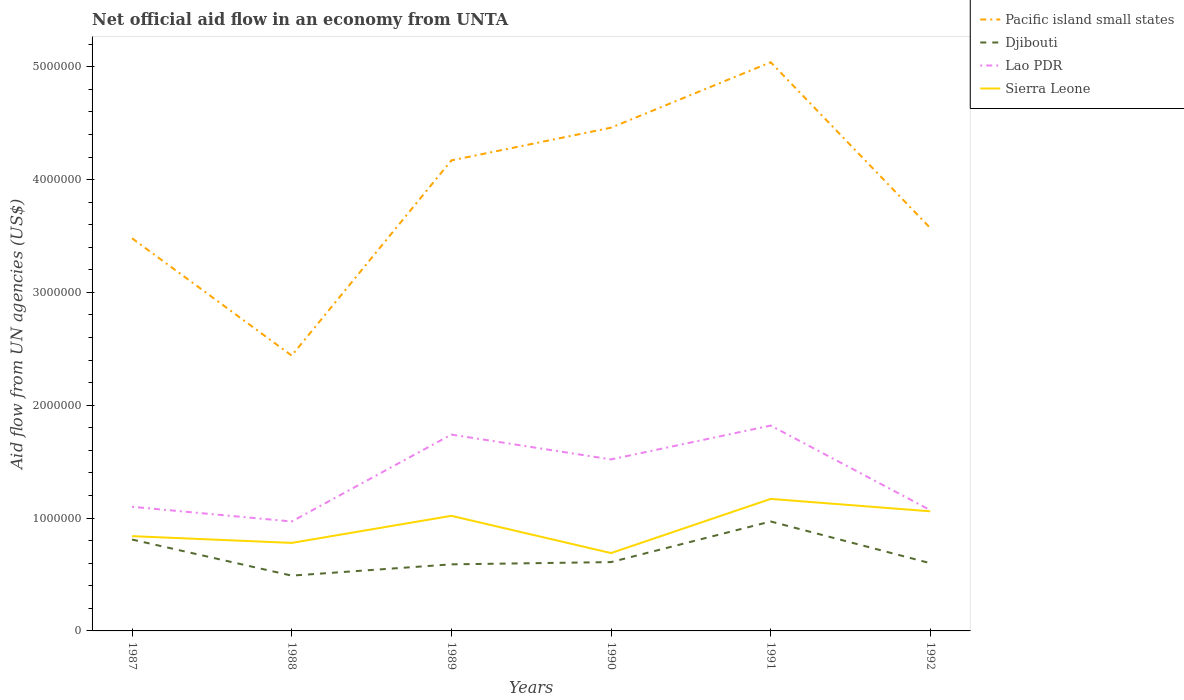How many different coloured lines are there?
Ensure brevity in your answer.  4. Does the line corresponding to Lao PDR intersect with the line corresponding to Pacific island small states?
Offer a terse response. No. Is the number of lines equal to the number of legend labels?
Keep it short and to the point. Yes. Across all years, what is the maximum net official aid flow in Pacific island small states?
Give a very brief answer. 2.44e+06. What is the total net official aid flow in Pacific island small states in the graph?
Ensure brevity in your answer.  -2.02e+06. What is the difference between the highest and the second highest net official aid flow in Lao PDR?
Make the answer very short. 8.50e+05. What is the difference between the highest and the lowest net official aid flow in Djibouti?
Your answer should be compact. 2. How many lines are there?
Ensure brevity in your answer.  4. Are the values on the major ticks of Y-axis written in scientific E-notation?
Your answer should be very brief. No. What is the title of the graph?
Your answer should be compact. Net official aid flow in an economy from UNTA. What is the label or title of the X-axis?
Provide a succinct answer. Years. What is the label or title of the Y-axis?
Ensure brevity in your answer.  Aid flow from UN agencies (US$). What is the Aid flow from UN agencies (US$) of Pacific island small states in 1987?
Make the answer very short. 3.48e+06. What is the Aid flow from UN agencies (US$) in Djibouti in 1987?
Provide a succinct answer. 8.10e+05. What is the Aid flow from UN agencies (US$) of Lao PDR in 1987?
Provide a succinct answer. 1.10e+06. What is the Aid flow from UN agencies (US$) of Sierra Leone in 1987?
Your response must be concise. 8.40e+05. What is the Aid flow from UN agencies (US$) of Pacific island small states in 1988?
Make the answer very short. 2.44e+06. What is the Aid flow from UN agencies (US$) in Lao PDR in 1988?
Offer a very short reply. 9.70e+05. What is the Aid flow from UN agencies (US$) of Sierra Leone in 1988?
Your response must be concise. 7.80e+05. What is the Aid flow from UN agencies (US$) of Pacific island small states in 1989?
Ensure brevity in your answer.  4.17e+06. What is the Aid flow from UN agencies (US$) of Djibouti in 1989?
Make the answer very short. 5.90e+05. What is the Aid flow from UN agencies (US$) in Lao PDR in 1989?
Give a very brief answer. 1.74e+06. What is the Aid flow from UN agencies (US$) in Sierra Leone in 1989?
Keep it short and to the point. 1.02e+06. What is the Aid flow from UN agencies (US$) of Pacific island small states in 1990?
Offer a very short reply. 4.46e+06. What is the Aid flow from UN agencies (US$) in Djibouti in 1990?
Provide a short and direct response. 6.10e+05. What is the Aid flow from UN agencies (US$) in Lao PDR in 1990?
Your response must be concise. 1.52e+06. What is the Aid flow from UN agencies (US$) of Sierra Leone in 1990?
Provide a short and direct response. 6.90e+05. What is the Aid flow from UN agencies (US$) in Pacific island small states in 1991?
Your answer should be compact. 5.04e+06. What is the Aid flow from UN agencies (US$) of Djibouti in 1991?
Your answer should be compact. 9.70e+05. What is the Aid flow from UN agencies (US$) of Lao PDR in 1991?
Keep it short and to the point. 1.82e+06. What is the Aid flow from UN agencies (US$) of Sierra Leone in 1991?
Offer a very short reply. 1.17e+06. What is the Aid flow from UN agencies (US$) of Pacific island small states in 1992?
Keep it short and to the point. 3.57e+06. What is the Aid flow from UN agencies (US$) of Lao PDR in 1992?
Ensure brevity in your answer.  1.07e+06. What is the Aid flow from UN agencies (US$) of Sierra Leone in 1992?
Keep it short and to the point. 1.06e+06. Across all years, what is the maximum Aid flow from UN agencies (US$) of Pacific island small states?
Your response must be concise. 5.04e+06. Across all years, what is the maximum Aid flow from UN agencies (US$) in Djibouti?
Provide a succinct answer. 9.70e+05. Across all years, what is the maximum Aid flow from UN agencies (US$) of Lao PDR?
Offer a very short reply. 1.82e+06. Across all years, what is the maximum Aid flow from UN agencies (US$) in Sierra Leone?
Keep it short and to the point. 1.17e+06. Across all years, what is the minimum Aid flow from UN agencies (US$) in Pacific island small states?
Your response must be concise. 2.44e+06. Across all years, what is the minimum Aid flow from UN agencies (US$) of Lao PDR?
Your answer should be compact. 9.70e+05. Across all years, what is the minimum Aid flow from UN agencies (US$) of Sierra Leone?
Offer a terse response. 6.90e+05. What is the total Aid flow from UN agencies (US$) in Pacific island small states in the graph?
Give a very brief answer. 2.32e+07. What is the total Aid flow from UN agencies (US$) of Djibouti in the graph?
Keep it short and to the point. 4.07e+06. What is the total Aid flow from UN agencies (US$) in Lao PDR in the graph?
Your answer should be compact. 8.22e+06. What is the total Aid flow from UN agencies (US$) of Sierra Leone in the graph?
Keep it short and to the point. 5.56e+06. What is the difference between the Aid flow from UN agencies (US$) of Pacific island small states in 1987 and that in 1988?
Provide a succinct answer. 1.04e+06. What is the difference between the Aid flow from UN agencies (US$) of Djibouti in 1987 and that in 1988?
Make the answer very short. 3.20e+05. What is the difference between the Aid flow from UN agencies (US$) of Lao PDR in 1987 and that in 1988?
Offer a terse response. 1.30e+05. What is the difference between the Aid flow from UN agencies (US$) of Sierra Leone in 1987 and that in 1988?
Your answer should be compact. 6.00e+04. What is the difference between the Aid flow from UN agencies (US$) in Pacific island small states in 1987 and that in 1989?
Ensure brevity in your answer.  -6.90e+05. What is the difference between the Aid flow from UN agencies (US$) in Lao PDR in 1987 and that in 1989?
Keep it short and to the point. -6.40e+05. What is the difference between the Aid flow from UN agencies (US$) of Pacific island small states in 1987 and that in 1990?
Your answer should be compact. -9.80e+05. What is the difference between the Aid flow from UN agencies (US$) of Djibouti in 1987 and that in 1990?
Ensure brevity in your answer.  2.00e+05. What is the difference between the Aid flow from UN agencies (US$) in Lao PDR in 1987 and that in 1990?
Provide a short and direct response. -4.20e+05. What is the difference between the Aid flow from UN agencies (US$) in Pacific island small states in 1987 and that in 1991?
Your answer should be compact. -1.56e+06. What is the difference between the Aid flow from UN agencies (US$) of Djibouti in 1987 and that in 1991?
Your response must be concise. -1.60e+05. What is the difference between the Aid flow from UN agencies (US$) of Lao PDR in 1987 and that in 1991?
Provide a succinct answer. -7.20e+05. What is the difference between the Aid flow from UN agencies (US$) in Sierra Leone in 1987 and that in 1991?
Your answer should be compact. -3.30e+05. What is the difference between the Aid flow from UN agencies (US$) in Pacific island small states in 1987 and that in 1992?
Offer a terse response. -9.00e+04. What is the difference between the Aid flow from UN agencies (US$) in Djibouti in 1987 and that in 1992?
Offer a very short reply. 2.10e+05. What is the difference between the Aid flow from UN agencies (US$) of Sierra Leone in 1987 and that in 1992?
Keep it short and to the point. -2.20e+05. What is the difference between the Aid flow from UN agencies (US$) of Pacific island small states in 1988 and that in 1989?
Offer a terse response. -1.73e+06. What is the difference between the Aid flow from UN agencies (US$) in Lao PDR in 1988 and that in 1989?
Your answer should be very brief. -7.70e+05. What is the difference between the Aid flow from UN agencies (US$) in Sierra Leone in 1988 and that in 1989?
Offer a terse response. -2.40e+05. What is the difference between the Aid flow from UN agencies (US$) of Pacific island small states in 1988 and that in 1990?
Your answer should be compact. -2.02e+06. What is the difference between the Aid flow from UN agencies (US$) in Lao PDR in 1988 and that in 1990?
Keep it short and to the point. -5.50e+05. What is the difference between the Aid flow from UN agencies (US$) in Sierra Leone in 1988 and that in 1990?
Your answer should be very brief. 9.00e+04. What is the difference between the Aid flow from UN agencies (US$) in Pacific island small states in 1988 and that in 1991?
Offer a terse response. -2.60e+06. What is the difference between the Aid flow from UN agencies (US$) in Djibouti in 1988 and that in 1991?
Give a very brief answer. -4.80e+05. What is the difference between the Aid flow from UN agencies (US$) in Lao PDR in 1988 and that in 1991?
Provide a short and direct response. -8.50e+05. What is the difference between the Aid flow from UN agencies (US$) of Sierra Leone in 1988 and that in 1991?
Keep it short and to the point. -3.90e+05. What is the difference between the Aid flow from UN agencies (US$) in Pacific island small states in 1988 and that in 1992?
Offer a terse response. -1.13e+06. What is the difference between the Aid flow from UN agencies (US$) of Djibouti in 1988 and that in 1992?
Keep it short and to the point. -1.10e+05. What is the difference between the Aid flow from UN agencies (US$) in Sierra Leone in 1988 and that in 1992?
Your answer should be compact. -2.80e+05. What is the difference between the Aid flow from UN agencies (US$) in Sierra Leone in 1989 and that in 1990?
Make the answer very short. 3.30e+05. What is the difference between the Aid flow from UN agencies (US$) of Pacific island small states in 1989 and that in 1991?
Ensure brevity in your answer.  -8.70e+05. What is the difference between the Aid flow from UN agencies (US$) of Djibouti in 1989 and that in 1991?
Provide a succinct answer. -3.80e+05. What is the difference between the Aid flow from UN agencies (US$) in Pacific island small states in 1989 and that in 1992?
Your response must be concise. 6.00e+05. What is the difference between the Aid flow from UN agencies (US$) of Lao PDR in 1989 and that in 1992?
Offer a very short reply. 6.70e+05. What is the difference between the Aid flow from UN agencies (US$) in Pacific island small states in 1990 and that in 1991?
Your response must be concise. -5.80e+05. What is the difference between the Aid flow from UN agencies (US$) in Djibouti in 1990 and that in 1991?
Offer a terse response. -3.60e+05. What is the difference between the Aid flow from UN agencies (US$) in Lao PDR in 1990 and that in 1991?
Ensure brevity in your answer.  -3.00e+05. What is the difference between the Aid flow from UN agencies (US$) in Sierra Leone in 1990 and that in 1991?
Make the answer very short. -4.80e+05. What is the difference between the Aid flow from UN agencies (US$) of Pacific island small states in 1990 and that in 1992?
Offer a very short reply. 8.90e+05. What is the difference between the Aid flow from UN agencies (US$) in Djibouti in 1990 and that in 1992?
Keep it short and to the point. 10000. What is the difference between the Aid flow from UN agencies (US$) in Sierra Leone in 1990 and that in 1992?
Your answer should be very brief. -3.70e+05. What is the difference between the Aid flow from UN agencies (US$) of Pacific island small states in 1991 and that in 1992?
Ensure brevity in your answer.  1.47e+06. What is the difference between the Aid flow from UN agencies (US$) in Lao PDR in 1991 and that in 1992?
Ensure brevity in your answer.  7.50e+05. What is the difference between the Aid flow from UN agencies (US$) of Pacific island small states in 1987 and the Aid flow from UN agencies (US$) of Djibouti in 1988?
Offer a terse response. 2.99e+06. What is the difference between the Aid flow from UN agencies (US$) in Pacific island small states in 1987 and the Aid flow from UN agencies (US$) in Lao PDR in 1988?
Make the answer very short. 2.51e+06. What is the difference between the Aid flow from UN agencies (US$) in Pacific island small states in 1987 and the Aid flow from UN agencies (US$) in Sierra Leone in 1988?
Give a very brief answer. 2.70e+06. What is the difference between the Aid flow from UN agencies (US$) in Pacific island small states in 1987 and the Aid flow from UN agencies (US$) in Djibouti in 1989?
Offer a very short reply. 2.89e+06. What is the difference between the Aid flow from UN agencies (US$) of Pacific island small states in 1987 and the Aid flow from UN agencies (US$) of Lao PDR in 1989?
Offer a very short reply. 1.74e+06. What is the difference between the Aid flow from UN agencies (US$) of Pacific island small states in 1987 and the Aid flow from UN agencies (US$) of Sierra Leone in 1989?
Give a very brief answer. 2.46e+06. What is the difference between the Aid flow from UN agencies (US$) in Djibouti in 1987 and the Aid flow from UN agencies (US$) in Lao PDR in 1989?
Your answer should be very brief. -9.30e+05. What is the difference between the Aid flow from UN agencies (US$) in Pacific island small states in 1987 and the Aid flow from UN agencies (US$) in Djibouti in 1990?
Provide a short and direct response. 2.87e+06. What is the difference between the Aid flow from UN agencies (US$) in Pacific island small states in 1987 and the Aid flow from UN agencies (US$) in Lao PDR in 1990?
Provide a short and direct response. 1.96e+06. What is the difference between the Aid flow from UN agencies (US$) of Pacific island small states in 1987 and the Aid flow from UN agencies (US$) of Sierra Leone in 1990?
Offer a very short reply. 2.79e+06. What is the difference between the Aid flow from UN agencies (US$) in Djibouti in 1987 and the Aid flow from UN agencies (US$) in Lao PDR in 1990?
Make the answer very short. -7.10e+05. What is the difference between the Aid flow from UN agencies (US$) of Djibouti in 1987 and the Aid flow from UN agencies (US$) of Sierra Leone in 1990?
Your answer should be very brief. 1.20e+05. What is the difference between the Aid flow from UN agencies (US$) of Pacific island small states in 1987 and the Aid flow from UN agencies (US$) of Djibouti in 1991?
Your response must be concise. 2.51e+06. What is the difference between the Aid flow from UN agencies (US$) in Pacific island small states in 1987 and the Aid flow from UN agencies (US$) in Lao PDR in 1991?
Your response must be concise. 1.66e+06. What is the difference between the Aid flow from UN agencies (US$) of Pacific island small states in 1987 and the Aid flow from UN agencies (US$) of Sierra Leone in 1991?
Your answer should be very brief. 2.31e+06. What is the difference between the Aid flow from UN agencies (US$) in Djibouti in 1987 and the Aid flow from UN agencies (US$) in Lao PDR in 1991?
Provide a short and direct response. -1.01e+06. What is the difference between the Aid flow from UN agencies (US$) in Djibouti in 1987 and the Aid flow from UN agencies (US$) in Sierra Leone in 1991?
Provide a succinct answer. -3.60e+05. What is the difference between the Aid flow from UN agencies (US$) in Pacific island small states in 1987 and the Aid flow from UN agencies (US$) in Djibouti in 1992?
Offer a very short reply. 2.88e+06. What is the difference between the Aid flow from UN agencies (US$) in Pacific island small states in 1987 and the Aid flow from UN agencies (US$) in Lao PDR in 1992?
Offer a very short reply. 2.41e+06. What is the difference between the Aid flow from UN agencies (US$) of Pacific island small states in 1987 and the Aid flow from UN agencies (US$) of Sierra Leone in 1992?
Provide a short and direct response. 2.42e+06. What is the difference between the Aid flow from UN agencies (US$) in Pacific island small states in 1988 and the Aid flow from UN agencies (US$) in Djibouti in 1989?
Provide a short and direct response. 1.85e+06. What is the difference between the Aid flow from UN agencies (US$) of Pacific island small states in 1988 and the Aid flow from UN agencies (US$) of Lao PDR in 1989?
Ensure brevity in your answer.  7.00e+05. What is the difference between the Aid flow from UN agencies (US$) of Pacific island small states in 1988 and the Aid flow from UN agencies (US$) of Sierra Leone in 1989?
Offer a very short reply. 1.42e+06. What is the difference between the Aid flow from UN agencies (US$) of Djibouti in 1988 and the Aid flow from UN agencies (US$) of Lao PDR in 1989?
Provide a succinct answer. -1.25e+06. What is the difference between the Aid flow from UN agencies (US$) of Djibouti in 1988 and the Aid flow from UN agencies (US$) of Sierra Leone in 1989?
Ensure brevity in your answer.  -5.30e+05. What is the difference between the Aid flow from UN agencies (US$) of Lao PDR in 1988 and the Aid flow from UN agencies (US$) of Sierra Leone in 1989?
Your response must be concise. -5.00e+04. What is the difference between the Aid flow from UN agencies (US$) of Pacific island small states in 1988 and the Aid flow from UN agencies (US$) of Djibouti in 1990?
Your answer should be very brief. 1.83e+06. What is the difference between the Aid flow from UN agencies (US$) of Pacific island small states in 1988 and the Aid flow from UN agencies (US$) of Lao PDR in 1990?
Offer a terse response. 9.20e+05. What is the difference between the Aid flow from UN agencies (US$) in Pacific island small states in 1988 and the Aid flow from UN agencies (US$) in Sierra Leone in 1990?
Your response must be concise. 1.75e+06. What is the difference between the Aid flow from UN agencies (US$) in Djibouti in 1988 and the Aid flow from UN agencies (US$) in Lao PDR in 1990?
Ensure brevity in your answer.  -1.03e+06. What is the difference between the Aid flow from UN agencies (US$) in Djibouti in 1988 and the Aid flow from UN agencies (US$) in Sierra Leone in 1990?
Keep it short and to the point. -2.00e+05. What is the difference between the Aid flow from UN agencies (US$) of Pacific island small states in 1988 and the Aid flow from UN agencies (US$) of Djibouti in 1991?
Your response must be concise. 1.47e+06. What is the difference between the Aid flow from UN agencies (US$) in Pacific island small states in 1988 and the Aid flow from UN agencies (US$) in Lao PDR in 1991?
Your answer should be very brief. 6.20e+05. What is the difference between the Aid flow from UN agencies (US$) in Pacific island small states in 1988 and the Aid flow from UN agencies (US$) in Sierra Leone in 1991?
Your answer should be compact. 1.27e+06. What is the difference between the Aid flow from UN agencies (US$) in Djibouti in 1988 and the Aid flow from UN agencies (US$) in Lao PDR in 1991?
Offer a terse response. -1.33e+06. What is the difference between the Aid flow from UN agencies (US$) of Djibouti in 1988 and the Aid flow from UN agencies (US$) of Sierra Leone in 1991?
Your answer should be compact. -6.80e+05. What is the difference between the Aid flow from UN agencies (US$) of Lao PDR in 1988 and the Aid flow from UN agencies (US$) of Sierra Leone in 1991?
Offer a very short reply. -2.00e+05. What is the difference between the Aid flow from UN agencies (US$) of Pacific island small states in 1988 and the Aid flow from UN agencies (US$) of Djibouti in 1992?
Provide a short and direct response. 1.84e+06. What is the difference between the Aid flow from UN agencies (US$) of Pacific island small states in 1988 and the Aid flow from UN agencies (US$) of Lao PDR in 1992?
Ensure brevity in your answer.  1.37e+06. What is the difference between the Aid flow from UN agencies (US$) of Pacific island small states in 1988 and the Aid flow from UN agencies (US$) of Sierra Leone in 1992?
Offer a very short reply. 1.38e+06. What is the difference between the Aid flow from UN agencies (US$) of Djibouti in 1988 and the Aid flow from UN agencies (US$) of Lao PDR in 1992?
Ensure brevity in your answer.  -5.80e+05. What is the difference between the Aid flow from UN agencies (US$) of Djibouti in 1988 and the Aid flow from UN agencies (US$) of Sierra Leone in 1992?
Your response must be concise. -5.70e+05. What is the difference between the Aid flow from UN agencies (US$) in Pacific island small states in 1989 and the Aid flow from UN agencies (US$) in Djibouti in 1990?
Offer a very short reply. 3.56e+06. What is the difference between the Aid flow from UN agencies (US$) in Pacific island small states in 1989 and the Aid flow from UN agencies (US$) in Lao PDR in 1990?
Provide a short and direct response. 2.65e+06. What is the difference between the Aid flow from UN agencies (US$) of Pacific island small states in 1989 and the Aid flow from UN agencies (US$) of Sierra Leone in 1990?
Give a very brief answer. 3.48e+06. What is the difference between the Aid flow from UN agencies (US$) in Djibouti in 1989 and the Aid flow from UN agencies (US$) in Lao PDR in 1990?
Make the answer very short. -9.30e+05. What is the difference between the Aid flow from UN agencies (US$) of Lao PDR in 1989 and the Aid flow from UN agencies (US$) of Sierra Leone in 1990?
Your response must be concise. 1.05e+06. What is the difference between the Aid flow from UN agencies (US$) of Pacific island small states in 1989 and the Aid flow from UN agencies (US$) of Djibouti in 1991?
Offer a terse response. 3.20e+06. What is the difference between the Aid flow from UN agencies (US$) of Pacific island small states in 1989 and the Aid flow from UN agencies (US$) of Lao PDR in 1991?
Provide a short and direct response. 2.35e+06. What is the difference between the Aid flow from UN agencies (US$) of Pacific island small states in 1989 and the Aid flow from UN agencies (US$) of Sierra Leone in 1991?
Ensure brevity in your answer.  3.00e+06. What is the difference between the Aid flow from UN agencies (US$) in Djibouti in 1989 and the Aid flow from UN agencies (US$) in Lao PDR in 1991?
Offer a terse response. -1.23e+06. What is the difference between the Aid flow from UN agencies (US$) of Djibouti in 1989 and the Aid flow from UN agencies (US$) of Sierra Leone in 1991?
Make the answer very short. -5.80e+05. What is the difference between the Aid flow from UN agencies (US$) in Lao PDR in 1989 and the Aid flow from UN agencies (US$) in Sierra Leone in 1991?
Provide a succinct answer. 5.70e+05. What is the difference between the Aid flow from UN agencies (US$) in Pacific island small states in 1989 and the Aid flow from UN agencies (US$) in Djibouti in 1992?
Keep it short and to the point. 3.57e+06. What is the difference between the Aid flow from UN agencies (US$) in Pacific island small states in 1989 and the Aid flow from UN agencies (US$) in Lao PDR in 1992?
Provide a succinct answer. 3.10e+06. What is the difference between the Aid flow from UN agencies (US$) of Pacific island small states in 1989 and the Aid flow from UN agencies (US$) of Sierra Leone in 1992?
Make the answer very short. 3.11e+06. What is the difference between the Aid flow from UN agencies (US$) in Djibouti in 1989 and the Aid flow from UN agencies (US$) in Lao PDR in 1992?
Give a very brief answer. -4.80e+05. What is the difference between the Aid flow from UN agencies (US$) in Djibouti in 1989 and the Aid flow from UN agencies (US$) in Sierra Leone in 1992?
Your answer should be compact. -4.70e+05. What is the difference between the Aid flow from UN agencies (US$) in Lao PDR in 1989 and the Aid flow from UN agencies (US$) in Sierra Leone in 1992?
Your response must be concise. 6.80e+05. What is the difference between the Aid flow from UN agencies (US$) in Pacific island small states in 1990 and the Aid flow from UN agencies (US$) in Djibouti in 1991?
Provide a succinct answer. 3.49e+06. What is the difference between the Aid flow from UN agencies (US$) of Pacific island small states in 1990 and the Aid flow from UN agencies (US$) of Lao PDR in 1991?
Make the answer very short. 2.64e+06. What is the difference between the Aid flow from UN agencies (US$) of Pacific island small states in 1990 and the Aid flow from UN agencies (US$) of Sierra Leone in 1991?
Provide a succinct answer. 3.29e+06. What is the difference between the Aid flow from UN agencies (US$) of Djibouti in 1990 and the Aid flow from UN agencies (US$) of Lao PDR in 1991?
Your answer should be very brief. -1.21e+06. What is the difference between the Aid flow from UN agencies (US$) in Djibouti in 1990 and the Aid flow from UN agencies (US$) in Sierra Leone in 1991?
Your answer should be compact. -5.60e+05. What is the difference between the Aid flow from UN agencies (US$) of Pacific island small states in 1990 and the Aid flow from UN agencies (US$) of Djibouti in 1992?
Give a very brief answer. 3.86e+06. What is the difference between the Aid flow from UN agencies (US$) in Pacific island small states in 1990 and the Aid flow from UN agencies (US$) in Lao PDR in 1992?
Provide a succinct answer. 3.39e+06. What is the difference between the Aid flow from UN agencies (US$) of Pacific island small states in 1990 and the Aid flow from UN agencies (US$) of Sierra Leone in 1992?
Provide a succinct answer. 3.40e+06. What is the difference between the Aid flow from UN agencies (US$) of Djibouti in 1990 and the Aid flow from UN agencies (US$) of Lao PDR in 1992?
Offer a very short reply. -4.60e+05. What is the difference between the Aid flow from UN agencies (US$) of Djibouti in 1990 and the Aid flow from UN agencies (US$) of Sierra Leone in 1992?
Offer a terse response. -4.50e+05. What is the difference between the Aid flow from UN agencies (US$) in Lao PDR in 1990 and the Aid flow from UN agencies (US$) in Sierra Leone in 1992?
Your answer should be very brief. 4.60e+05. What is the difference between the Aid flow from UN agencies (US$) of Pacific island small states in 1991 and the Aid flow from UN agencies (US$) of Djibouti in 1992?
Provide a succinct answer. 4.44e+06. What is the difference between the Aid flow from UN agencies (US$) of Pacific island small states in 1991 and the Aid flow from UN agencies (US$) of Lao PDR in 1992?
Ensure brevity in your answer.  3.97e+06. What is the difference between the Aid flow from UN agencies (US$) of Pacific island small states in 1991 and the Aid flow from UN agencies (US$) of Sierra Leone in 1992?
Ensure brevity in your answer.  3.98e+06. What is the difference between the Aid flow from UN agencies (US$) of Djibouti in 1991 and the Aid flow from UN agencies (US$) of Sierra Leone in 1992?
Give a very brief answer. -9.00e+04. What is the difference between the Aid flow from UN agencies (US$) of Lao PDR in 1991 and the Aid flow from UN agencies (US$) of Sierra Leone in 1992?
Give a very brief answer. 7.60e+05. What is the average Aid flow from UN agencies (US$) in Pacific island small states per year?
Offer a very short reply. 3.86e+06. What is the average Aid flow from UN agencies (US$) of Djibouti per year?
Give a very brief answer. 6.78e+05. What is the average Aid flow from UN agencies (US$) of Lao PDR per year?
Your answer should be compact. 1.37e+06. What is the average Aid flow from UN agencies (US$) in Sierra Leone per year?
Your response must be concise. 9.27e+05. In the year 1987, what is the difference between the Aid flow from UN agencies (US$) in Pacific island small states and Aid flow from UN agencies (US$) in Djibouti?
Your answer should be very brief. 2.67e+06. In the year 1987, what is the difference between the Aid flow from UN agencies (US$) in Pacific island small states and Aid flow from UN agencies (US$) in Lao PDR?
Provide a short and direct response. 2.38e+06. In the year 1987, what is the difference between the Aid flow from UN agencies (US$) in Pacific island small states and Aid flow from UN agencies (US$) in Sierra Leone?
Your answer should be compact. 2.64e+06. In the year 1987, what is the difference between the Aid flow from UN agencies (US$) in Lao PDR and Aid flow from UN agencies (US$) in Sierra Leone?
Your answer should be very brief. 2.60e+05. In the year 1988, what is the difference between the Aid flow from UN agencies (US$) of Pacific island small states and Aid flow from UN agencies (US$) of Djibouti?
Offer a terse response. 1.95e+06. In the year 1988, what is the difference between the Aid flow from UN agencies (US$) of Pacific island small states and Aid flow from UN agencies (US$) of Lao PDR?
Ensure brevity in your answer.  1.47e+06. In the year 1988, what is the difference between the Aid flow from UN agencies (US$) in Pacific island small states and Aid flow from UN agencies (US$) in Sierra Leone?
Keep it short and to the point. 1.66e+06. In the year 1988, what is the difference between the Aid flow from UN agencies (US$) of Djibouti and Aid flow from UN agencies (US$) of Lao PDR?
Provide a short and direct response. -4.80e+05. In the year 1988, what is the difference between the Aid flow from UN agencies (US$) in Lao PDR and Aid flow from UN agencies (US$) in Sierra Leone?
Offer a very short reply. 1.90e+05. In the year 1989, what is the difference between the Aid flow from UN agencies (US$) in Pacific island small states and Aid flow from UN agencies (US$) in Djibouti?
Your response must be concise. 3.58e+06. In the year 1989, what is the difference between the Aid flow from UN agencies (US$) of Pacific island small states and Aid flow from UN agencies (US$) of Lao PDR?
Give a very brief answer. 2.43e+06. In the year 1989, what is the difference between the Aid flow from UN agencies (US$) of Pacific island small states and Aid flow from UN agencies (US$) of Sierra Leone?
Keep it short and to the point. 3.15e+06. In the year 1989, what is the difference between the Aid flow from UN agencies (US$) in Djibouti and Aid flow from UN agencies (US$) in Lao PDR?
Provide a succinct answer. -1.15e+06. In the year 1989, what is the difference between the Aid flow from UN agencies (US$) of Djibouti and Aid flow from UN agencies (US$) of Sierra Leone?
Offer a terse response. -4.30e+05. In the year 1989, what is the difference between the Aid flow from UN agencies (US$) of Lao PDR and Aid flow from UN agencies (US$) of Sierra Leone?
Give a very brief answer. 7.20e+05. In the year 1990, what is the difference between the Aid flow from UN agencies (US$) in Pacific island small states and Aid flow from UN agencies (US$) in Djibouti?
Ensure brevity in your answer.  3.85e+06. In the year 1990, what is the difference between the Aid flow from UN agencies (US$) in Pacific island small states and Aid flow from UN agencies (US$) in Lao PDR?
Provide a short and direct response. 2.94e+06. In the year 1990, what is the difference between the Aid flow from UN agencies (US$) in Pacific island small states and Aid flow from UN agencies (US$) in Sierra Leone?
Your response must be concise. 3.77e+06. In the year 1990, what is the difference between the Aid flow from UN agencies (US$) in Djibouti and Aid flow from UN agencies (US$) in Lao PDR?
Offer a very short reply. -9.10e+05. In the year 1990, what is the difference between the Aid flow from UN agencies (US$) of Lao PDR and Aid flow from UN agencies (US$) of Sierra Leone?
Your answer should be very brief. 8.30e+05. In the year 1991, what is the difference between the Aid flow from UN agencies (US$) of Pacific island small states and Aid flow from UN agencies (US$) of Djibouti?
Keep it short and to the point. 4.07e+06. In the year 1991, what is the difference between the Aid flow from UN agencies (US$) in Pacific island small states and Aid flow from UN agencies (US$) in Lao PDR?
Your answer should be very brief. 3.22e+06. In the year 1991, what is the difference between the Aid flow from UN agencies (US$) of Pacific island small states and Aid flow from UN agencies (US$) of Sierra Leone?
Make the answer very short. 3.87e+06. In the year 1991, what is the difference between the Aid flow from UN agencies (US$) in Djibouti and Aid flow from UN agencies (US$) in Lao PDR?
Your answer should be compact. -8.50e+05. In the year 1991, what is the difference between the Aid flow from UN agencies (US$) in Lao PDR and Aid flow from UN agencies (US$) in Sierra Leone?
Provide a succinct answer. 6.50e+05. In the year 1992, what is the difference between the Aid flow from UN agencies (US$) in Pacific island small states and Aid flow from UN agencies (US$) in Djibouti?
Ensure brevity in your answer.  2.97e+06. In the year 1992, what is the difference between the Aid flow from UN agencies (US$) of Pacific island small states and Aid flow from UN agencies (US$) of Lao PDR?
Give a very brief answer. 2.50e+06. In the year 1992, what is the difference between the Aid flow from UN agencies (US$) of Pacific island small states and Aid flow from UN agencies (US$) of Sierra Leone?
Ensure brevity in your answer.  2.51e+06. In the year 1992, what is the difference between the Aid flow from UN agencies (US$) in Djibouti and Aid flow from UN agencies (US$) in Lao PDR?
Ensure brevity in your answer.  -4.70e+05. In the year 1992, what is the difference between the Aid flow from UN agencies (US$) in Djibouti and Aid flow from UN agencies (US$) in Sierra Leone?
Offer a terse response. -4.60e+05. In the year 1992, what is the difference between the Aid flow from UN agencies (US$) in Lao PDR and Aid flow from UN agencies (US$) in Sierra Leone?
Your answer should be very brief. 10000. What is the ratio of the Aid flow from UN agencies (US$) in Pacific island small states in 1987 to that in 1988?
Your answer should be compact. 1.43. What is the ratio of the Aid flow from UN agencies (US$) in Djibouti in 1987 to that in 1988?
Keep it short and to the point. 1.65. What is the ratio of the Aid flow from UN agencies (US$) of Lao PDR in 1987 to that in 1988?
Offer a very short reply. 1.13. What is the ratio of the Aid flow from UN agencies (US$) in Sierra Leone in 1987 to that in 1988?
Give a very brief answer. 1.08. What is the ratio of the Aid flow from UN agencies (US$) of Pacific island small states in 1987 to that in 1989?
Offer a very short reply. 0.83. What is the ratio of the Aid flow from UN agencies (US$) of Djibouti in 1987 to that in 1989?
Your response must be concise. 1.37. What is the ratio of the Aid flow from UN agencies (US$) in Lao PDR in 1987 to that in 1989?
Your answer should be compact. 0.63. What is the ratio of the Aid flow from UN agencies (US$) in Sierra Leone in 1987 to that in 1989?
Keep it short and to the point. 0.82. What is the ratio of the Aid flow from UN agencies (US$) in Pacific island small states in 1987 to that in 1990?
Offer a very short reply. 0.78. What is the ratio of the Aid flow from UN agencies (US$) of Djibouti in 1987 to that in 1990?
Provide a succinct answer. 1.33. What is the ratio of the Aid flow from UN agencies (US$) of Lao PDR in 1987 to that in 1990?
Provide a succinct answer. 0.72. What is the ratio of the Aid flow from UN agencies (US$) in Sierra Leone in 1987 to that in 1990?
Your answer should be compact. 1.22. What is the ratio of the Aid flow from UN agencies (US$) of Pacific island small states in 1987 to that in 1991?
Provide a short and direct response. 0.69. What is the ratio of the Aid flow from UN agencies (US$) in Djibouti in 1987 to that in 1991?
Offer a terse response. 0.84. What is the ratio of the Aid flow from UN agencies (US$) in Lao PDR in 1987 to that in 1991?
Your response must be concise. 0.6. What is the ratio of the Aid flow from UN agencies (US$) in Sierra Leone in 1987 to that in 1991?
Give a very brief answer. 0.72. What is the ratio of the Aid flow from UN agencies (US$) in Pacific island small states in 1987 to that in 1992?
Offer a terse response. 0.97. What is the ratio of the Aid flow from UN agencies (US$) in Djibouti in 1987 to that in 1992?
Ensure brevity in your answer.  1.35. What is the ratio of the Aid flow from UN agencies (US$) in Lao PDR in 1987 to that in 1992?
Offer a very short reply. 1.03. What is the ratio of the Aid flow from UN agencies (US$) in Sierra Leone in 1987 to that in 1992?
Offer a terse response. 0.79. What is the ratio of the Aid flow from UN agencies (US$) of Pacific island small states in 1988 to that in 1989?
Give a very brief answer. 0.59. What is the ratio of the Aid flow from UN agencies (US$) in Djibouti in 1988 to that in 1989?
Your response must be concise. 0.83. What is the ratio of the Aid flow from UN agencies (US$) of Lao PDR in 1988 to that in 1989?
Make the answer very short. 0.56. What is the ratio of the Aid flow from UN agencies (US$) in Sierra Leone in 1988 to that in 1989?
Provide a succinct answer. 0.76. What is the ratio of the Aid flow from UN agencies (US$) in Pacific island small states in 1988 to that in 1990?
Keep it short and to the point. 0.55. What is the ratio of the Aid flow from UN agencies (US$) in Djibouti in 1988 to that in 1990?
Offer a terse response. 0.8. What is the ratio of the Aid flow from UN agencies (US$) of Lao PDR in 1988 to that in 1990?
Your answer should be very brief. 0.64. What is the ratio of the Aid flow from UN agencies (US$) of Sierra Leone in 1988 to that in 1990?
Offer a terse response. 1.13. What is the ratio of the Aid flow from UN agencies (US$) of Pacific island small states in 1988 to that in 1991?
Your answer should be very brief. 0.48. What is the ratio of the Aid flow from UN agencies (US$) in Djibouti in 1988 to that in 1991?
Make the answer very short. 0.51. What is the ratio of the Aid flow from UN agencies (US$) in Lao PDR in 1988 to that in 1991?
Give a very brief answer. 0.53. What is the ratio of the Aid flow from UN agencies (US$) in Pacific island small states in 1988 to that in 1992?
Ensure brevity in your answer.  0.68. What is the ratio of the Aid flow from UN agencies (US$) of Djibouti in 1988 to that in 1992?
Your answer should be very brief. 0.82. What is the ratio of the Aid flow from UN agencies (US$) of Lao PDR in 1988 to that in 1992?
Give a very brief answer. 0.91. What is the ratio of the Aid flow from UN agencies (US$) in Sierra Leone in 1988 to that in 1992?
Your answer should be compact. 0.74. What is the ratio of the Aid flow from UN agencies (US$) of Pacific island small states in 1989 to that in 1990?
Keep it short and to the point. 0.94. What is the ratio of the Aid flow from UN agencies (US$) of Djibouti in 1989 to that in 1990?
Your response must be concise. 0.97. What is the ratio of the Aid flow from UN agencies (US$) in Lao PDR in 1989 to that in 1990?
Provide a succinct answer. 1.14. What is the ratio of the Aid flow from UN agencies (US$) in Sierra Leone in 1989 to that in 1990?
Your answer should be compact. 1.48. What is the ratio of the Aid flow from UN agencies (US$) in Pacific island small states in 1989 to that in 1991?
Make the answer very short. 0.83. What is the ratio of the Aid flow from UN agencies (US$) of Djibouti in 1989 to that in 1991?
Your response must be concise. 0.61. What is the ratio of the Aid flow from UN agencies (US$) in Lao PDR in 1989 to that in 1991?
Make the answer very short. 0.96. What is the ratio of the Aid flow from UN agencies (US$) in Sierra Leone in 1989 to that in 1991?
Your answer should be very brief. 0.87. What is the ratio of the Aid flow from UN agencies (US$) of Pacific island small states in 1989 to that in 1992?
Your answer should be compact. 1.17. What is the ratio of the Aid flow from UN agencies (US$) of Djibouti in 1989 to that in 1992?
Make the answer very short. 0.98. What is the ratio of the Aid flow from UN agencies (US$) of Lao PDR in 1989 to that in 1992?
Your response must be concise. 1.63. What is the ratio of the Aid flow from UN agencies (US$) of Sierra Leone in 1989 to that in 1992?
Your response must be concise. 0.96. What is the ratio of the Aid flow from UN agencies (US$) of Pacific island small states in 1990 to that in 1991?
Offer a very short reply. 0.88. What is the ratio of the Aid flow from UN agencies (US$) of Djibouti in 1990 to that in 1991?
Your answer should be compact. 0.63. What is the ratio of the Aid flow from UN agencies (US$) in Lao PDR in 1990 to that in 1991?
Provide a succinct answer. 0.84. What is the ratio of the Aid flow from UN agencies (US$) in Sierra Leone in 1990 to that in 1991?
Your response must be concise. 0.59. What is the ratio of the Aid flow from UN agencies (US$) of Pacific island small states in 1990 to that in 1992?
Your response must be concise. 1.25. What is the ratio of the Aid flow from UN agencies (US$) of Djibouti in 1990 to that in 1992?
Offer a very short reply. 1.02. What is the ratio of the Aid flow from UN agencies (US$) in Lao PDR in 1990 to that in 1992?
Provide a succinct answer. 1.42. What is the ratio of the Aid flow from UN agencies (US$) of Sierra Leone in 1990 to that in 1992?
Keep it short and to the point. 0.65. What is the ratio of the Aid flow from UN agencies (US$) in Pacific island small states in 1991 to that in 1992?
Ensure brevity in your answer.  1.41. What is the ratio of the Aid flow from UN agencies (US$) of Djibouti in 1991 to that in 1992?
Ensure brevity in your answer.  1.62. What is the ratio of the Aid flow from UN agencies (US$) in Lao PDR in 1991 to that in 1992?
Your answer should be very brief. 1.7. What is the ratio of the Aid flow from UN agencies (US$) in Sierra Leone in 1991 to that in 1992?
Offer a very short reply. 1.1. What is the difference between the highest and the second highest Aid flow from UN agencies (US$) in Pacific island small states?
Your response must be concise. 5.80e+05. What is the difference between the highest and the lowest Aid flow from UN agencies (US$) of Pacific island small states?
Offer a very short reply. 2.60e+06. What is the difference between the highest and the lowest Aid flow from UN agencies (US$) of Lao PDR?
Your answer should be compact. 8.50e+05. 